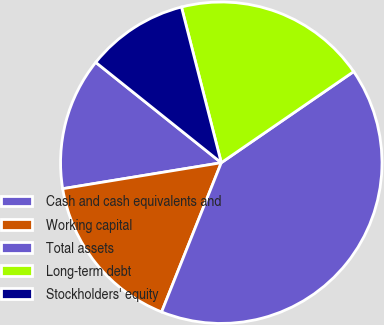Convert chart. <chart><loc_0><loc_0><loc_500><loc_500><pie_chart><fcel>Cash and cash equivalents and<fcel>Working capital<fcel>Total assets<fcel>Long-term debt<fcel>Stockholders' equity<nl><fcel>13.32%<fcel>16.36%<fcel>40.65%<fcel>19.39%<fcel>10.28%<nl></chart> 